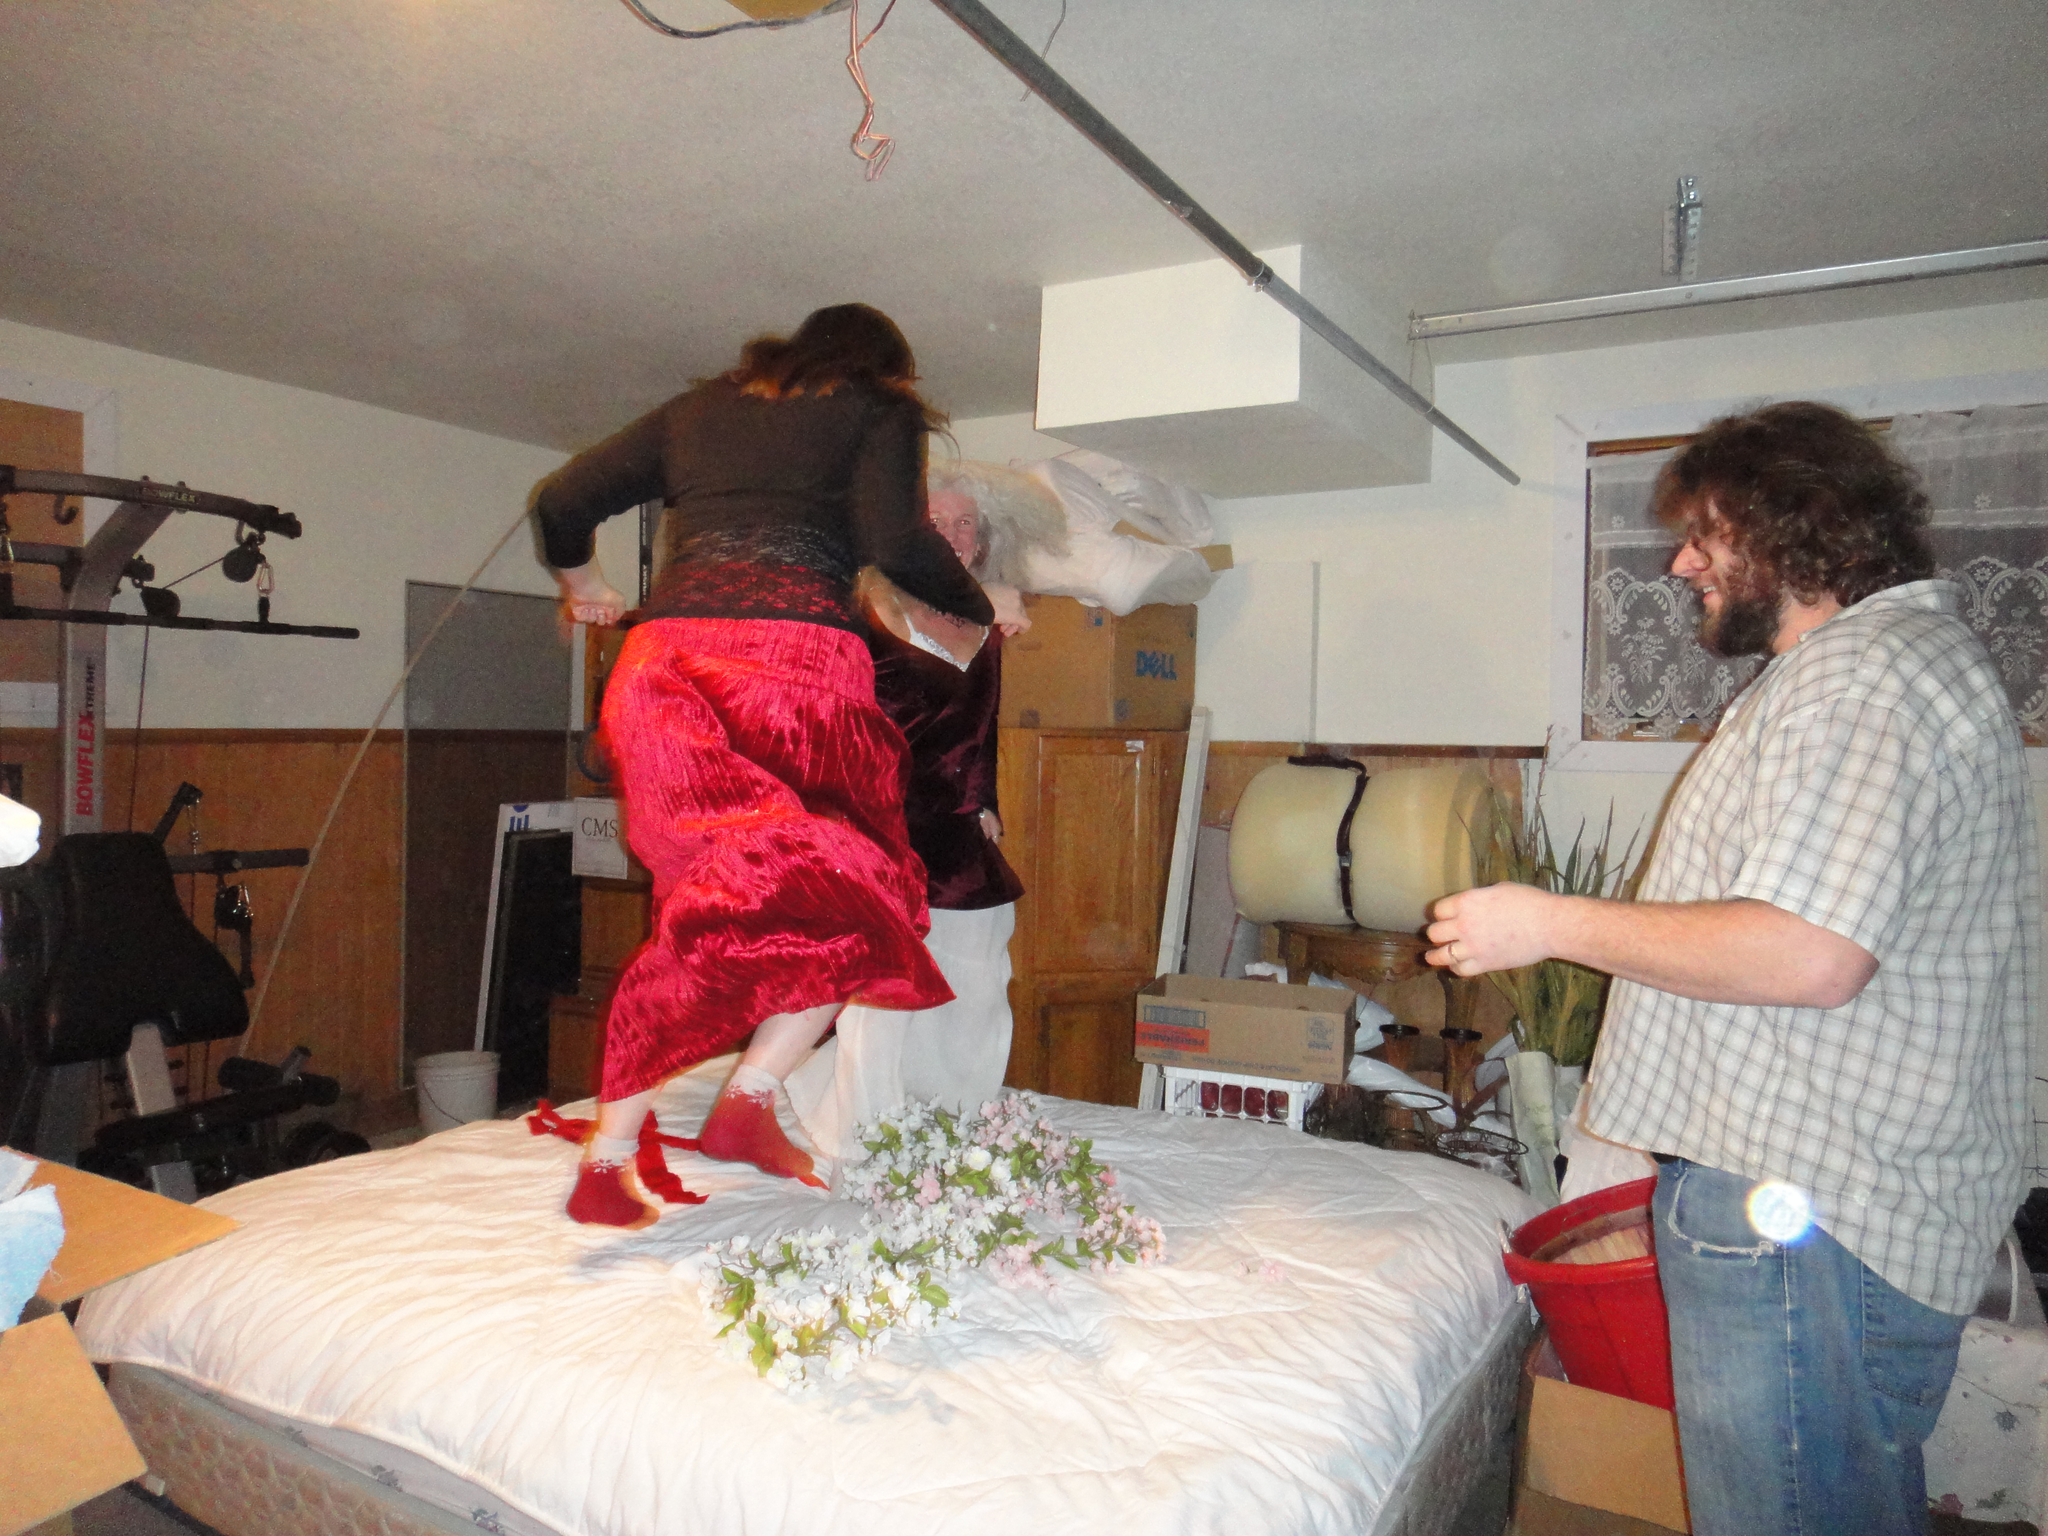Could you give a brief overview of what you see in this image? In this image there is a women with black shirt and red skirt, she is jumping on the bed. There is an another women sitting on the bed, there is a man standing at the bed. There is a red tub on a cardboard box behind the man, there is a plant and stool at the back and at the left there is a machine and the top there is a wire. 